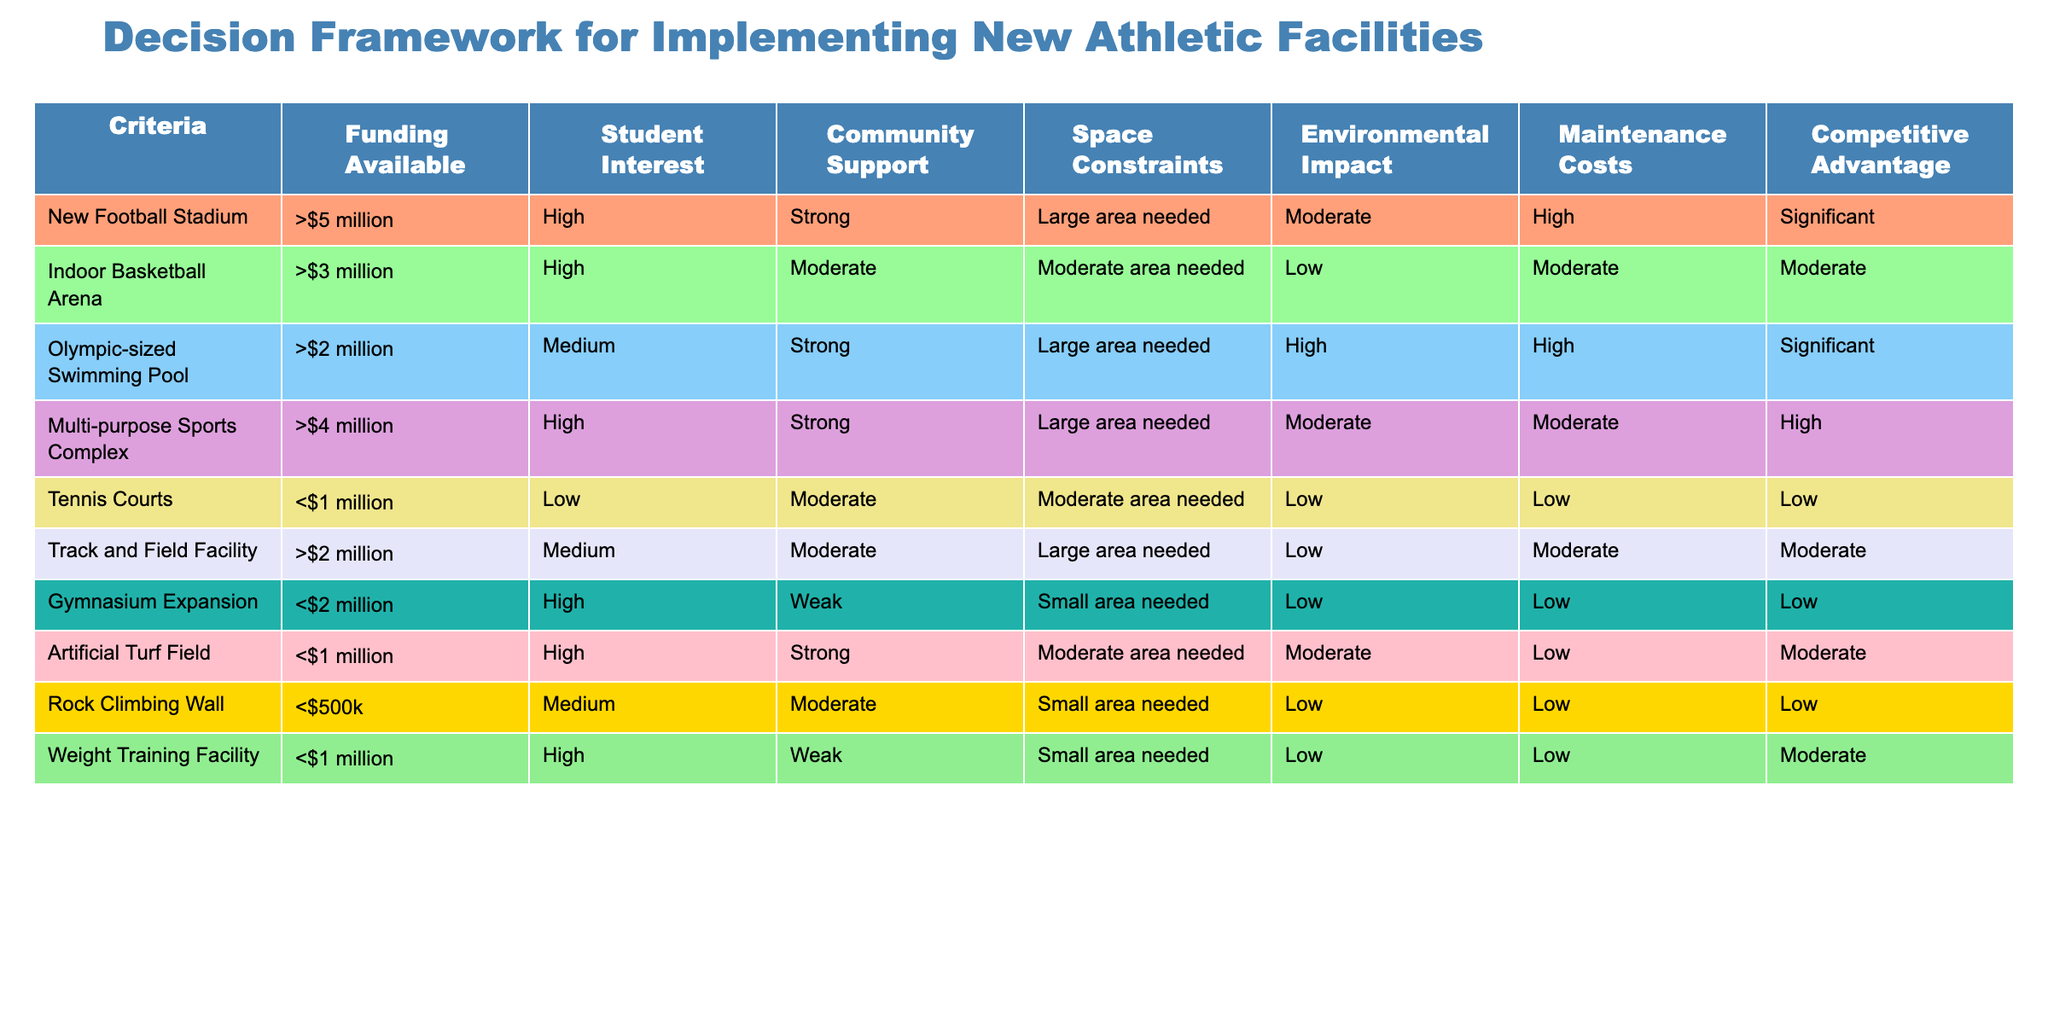What is the funding available for the Indoor Basketball Arena? The table indicates that the funding available for the Indoor Basketball Arena is greater than $3 million.
Answer: >$3 million How many facilities have a "High" student interest? By scanning the table, I see that the New Football Stadium, Indoor Basketball Arena, Multi-purpose Sports Complex, Gymnasium Expansion, and Weight Training Facility all list "High" for student interest. That totals to five facilities.
Answer: 5 Is the Environmental Impact for the Olympic-sized Swimming Pool low? The Environmental Impact for the Olympic-sized Swimming Pool is listed as "High," which is not considered low; hence the answer is no.
Answer: No What is the total maintenance cost rating of the top three facilities (by funding) based on the rankings provided? The top three facilities by funding, New Football Stadium, Indoor Basketball Arena, and Olympic-sized Swimming Pool, have maintenance cost ratings of High, Moderate, and High, respectively. When summed as numerical values (assuming High=3, Moderate=2, Low=1), it results in 3 + 2 + 3 = 8.
Answer: 8 Are there any facilities that support both "Strong" community support and "High" student interest? Yes, the New Football Stadium, Indoor Basketball Arena, and Multi-purpose Sports Complex show both "Strong" community support and "High" student interest according to the table.
Answer: Yes What is the only facility with a competitive advantage rating of "Low"? The table indicates that the Tennis Courts are the only facility with a competitive advantage rating of "Low."
Answer: Tennis Courts What percentage of the facilities listed have space constraints categorized as "Large area needed"? From the table, six out of ten facilities have space constraints categorized as "Large area needed." To find the percentage, the calculation is (6/10) * 100 = 60%.
Answer: 60% If we compare the maintenance costs of the New Football Stadium and the Indoor Basketball Arena, which one has a lower cost rating? The New Football Stadium has a maintenance cost rating of "High," while the Indoor Basketball Arena has a rating of "Moderate." Since "Moderate" is lower than "High," the Indoor Basketball Arena has the lower maintenance cost rating.
Answer: Indoor Basketball Arena How many facilities are available under $1 million? The table shows three facilities under $1 million: Tennis Courts, Artificial Turf Field, and Rock Climbing Wall. Thus, the total is three facilities.
Answer: 3 